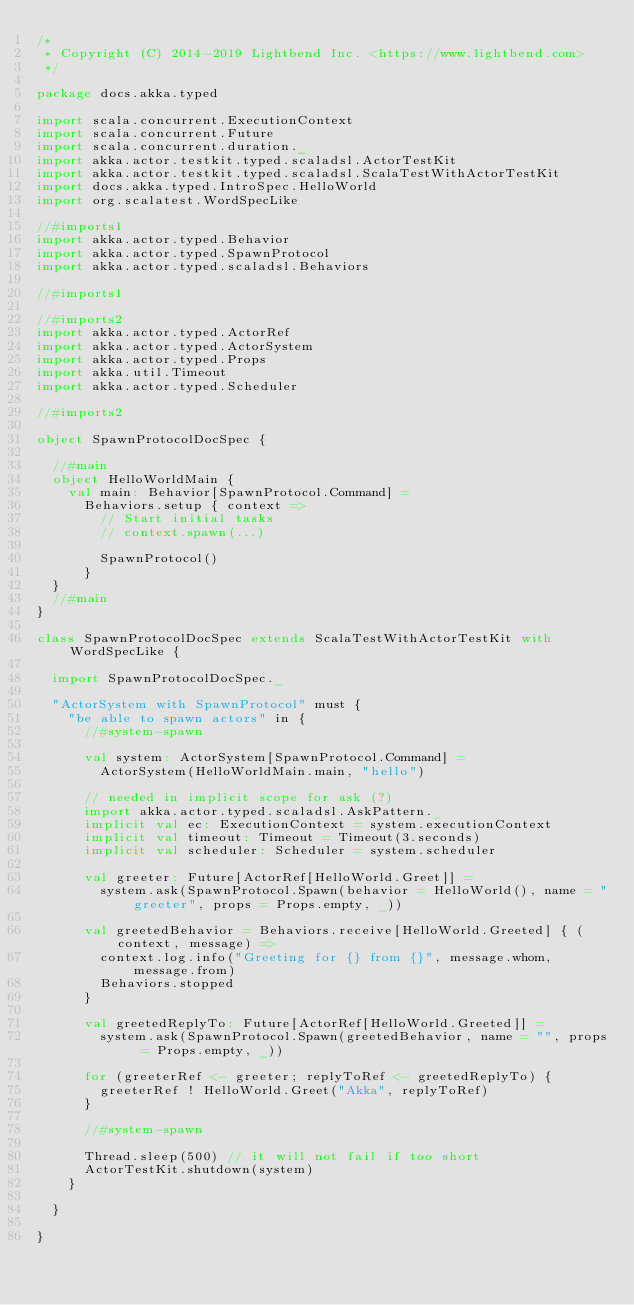Convert code to text. <code><loc_0><loc_0><loc_500><loc_500><_Scala_>/*
 * Copyright (C) 2014-2019 Lightbend Inc. <https://www.lightbend.com>
 */

package docs.akka.typed

import scala.concurrent.ExecutionContext
import scala.concurrent.Future
import scala.concurrent.duration._
import akka.actor.testkit.typed.scaladsl.ActorTestKit
import akka.actor.testkit.typed.scaladsl.ScalaTestWithActorTestKit
import docs.akka.typed.IntroSpec.HelloWorld
import org.scalatest.WordSpecLike

//#imports1
import akka.actor.typed.Behavior
import akka.actor.typed.SpawnProtocol
import akka.actor.typed.scaladsl.Behaviors

//#imports1

//#imports2
import akka.actor.typed.ActorRef
import akka.actor.typed.ActorSystem
import akka.actor.typed.Props
import akka.util.Timeout
import akka.actor.typed.Scheduler

//#imports2

object SpawnProtocolDocSpec {

  //#main
  object HelloWorldMain {
    val main: Behavior[SpawnProtocol.Command] =
      Behaviors.setup { context =>
        // Start initial tasks
        // context.spawn(...)

        SpawnProtocol()
      }
  }
  //#main
}

class SpawnProtocolDocSpec extends ScalaTestWithActorTestKit with WordSpecLike {

  import SpawnProtocolDocSpec._

  "ActorSystem with SpawnProtocol" must {
    "be able to spawn actors" in {
      //#system-spawn

      val system: ActorSystem[SpawnProtocol.Command] =
        ActorSystem(HelloWorldMain.main, "hello")

      // needed in implicit scope for ask (?)
      import akka.actor.typed.scaladsl.AskPattern._
      implicit val ec: ExecutionContext = system.executionContext
      implicit val timeout: Timeout = Timeout(3.seconds)
      implicit val scheduler: Scheduler = system.scheduler

      val greeter: Future[ActorRef[HelloWorld.Greet]] =
        system.ask(SpawnProtocol.Spawn(behavior = HelloWorld(), name = "greeter", props = Props.empty, _))

      val greetedBehavior = Behaviors.receive[HelloWorld.Greeted] { (context, message) =>
        context.log.info("Greeting for {} from {}", message.whom, message.from)
        Behaviors.stopped
      }

      val greetedReplyTo: Future[ActorRef[HelloWorld.Greeted]] =
        system.ask(SpawnProtocol.Spawn(greetedBehavior, name = "", props = Props.empty, _))

      for (greeterRef <- greeter; replyToRef <- greetedReplyTo) {
        greeterRef ! HelloWorld.Greet("Akka", replyToRef)
      }

      //#system-spawn

      Thread.sleep(500) // it will not fail if too short
      ActorTestKit.shutdown(system)
    }

  }

}
</code> 